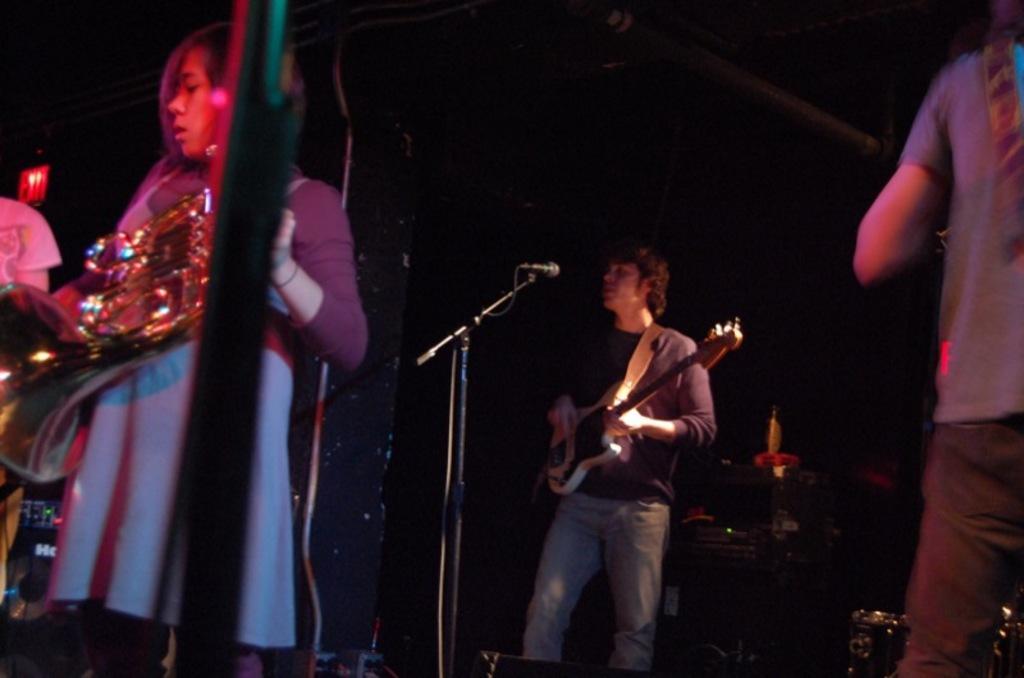Can you describe this image briefly? In the image we can see there are people who are holding guitar in their hand and a woman is holding a musical instrument. 